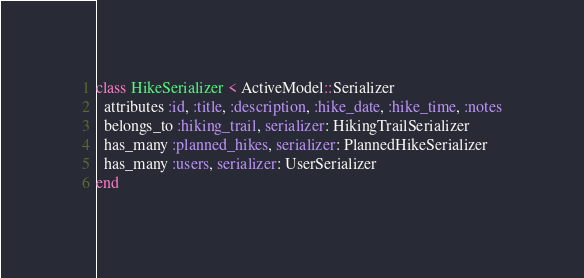<code> <loc_0><loc_0><loc_500><loc_500><_Ruby_>class HikeSerializer < ActiveModel::Serializer
  attributes :id, :title, :description, :hike_date, :hike_time, :notes
  belongs_to :hiking_trail, serializer: HikingTrailSerializer
  has_many :planned_hikes, serializer: PlannedHikeSerializer
  has_many :users, serializer: UserSerializer
end
</code> 